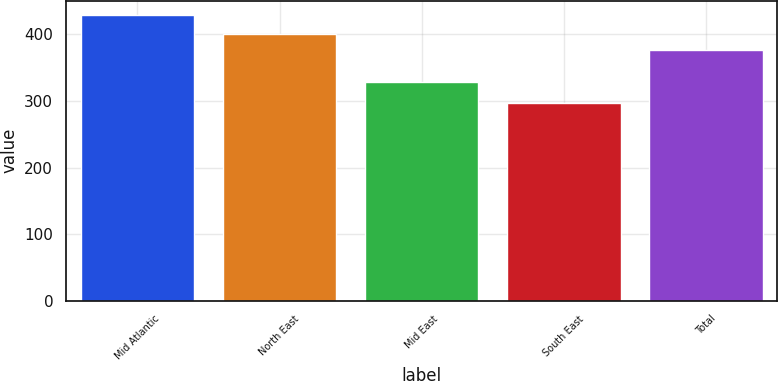Convert chart to OTSL. <chart><loc_0><loc_0><loc_500><loc_500><bar_chart><fcel>Mid Atlantic<fcel>North East<fcel>Mid East<fcel>South East<fcel>Total<nl><fcel>429.4<fcel>400.4<fcel>328<fcel>297.7<fcel>376.3<nl></chart> 